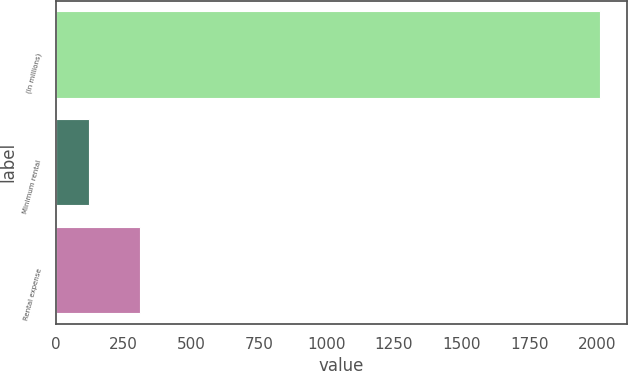Convert chart to OTSL. <chart><loc_0><loc_0><loc_500><loc_500><bar_chart><fcel>(In millions)<fcel>Minimum rental<fcel>Rental expense<nl><fcel>2011<fcel>123<fcel>311.8<nl></chart> 